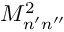<formula> <loc_0><loc_0><loc_500><loc_500>M _ { n ^ { \prime } n ^ { \prime \prime } } ^ { 2 }</formula> 